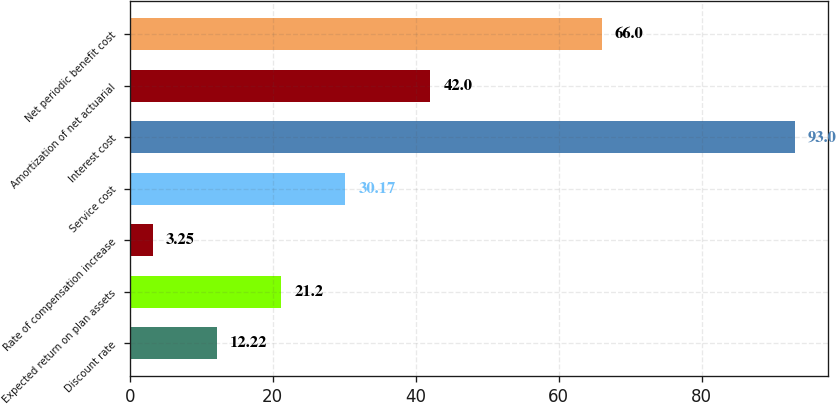Convert chart to OTSL. <chart><loc_0><loc_0><loc_500><loc_500><bar_chart><fcel>Discount rate<fcel>Expected return on plan assets<fcel>Rate of compensation increase<fcel>Service cost<fcel>Interest cost<fcel>Amortization of net actuarial<fcel>Net periodic benefit cost<nl><fcel>12.22<fcel>21.2<fcel>3.25<fcel>30.17<fcel>93<fcel>42<fcel>66<nl></chart> 